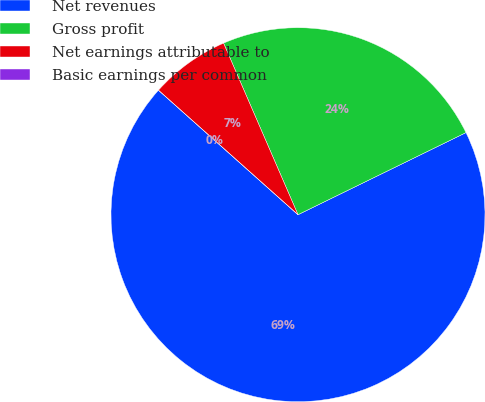Convert chart. <chart><loc_0><loc_0><loc_500><loc_500><pie_chart><fcel>Net revenues<fcel>Gross profit<fcel>Net earnings attributable to<fcel>Basic earnings per common<nl><fcel>68.83%<fcel>24.28%<fcel>6.89%<fcel>0.0%<nl></chart> 